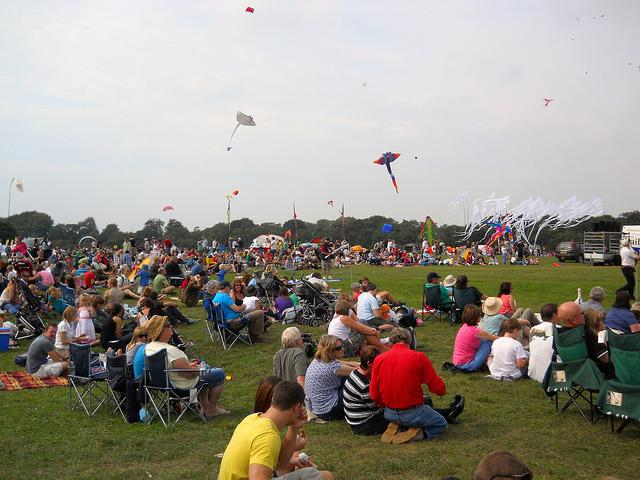Why are there more people than kites?

Choices:
A) lost some
B) lazy people
C) some hidden
D) mostly spectators mostly spectators 